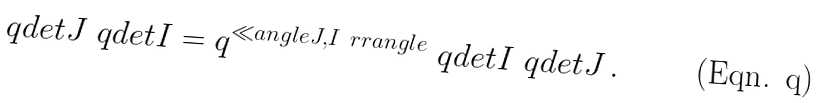<formula> <loc_0><loc_0><loc_500><loc_500>\ q d e t { J } \ q d e t { I } = q ^ { \ll a n g l e J , I \ r r a n g l e } \ q d e t { I } \ q d e t { J } \, .</formula> 